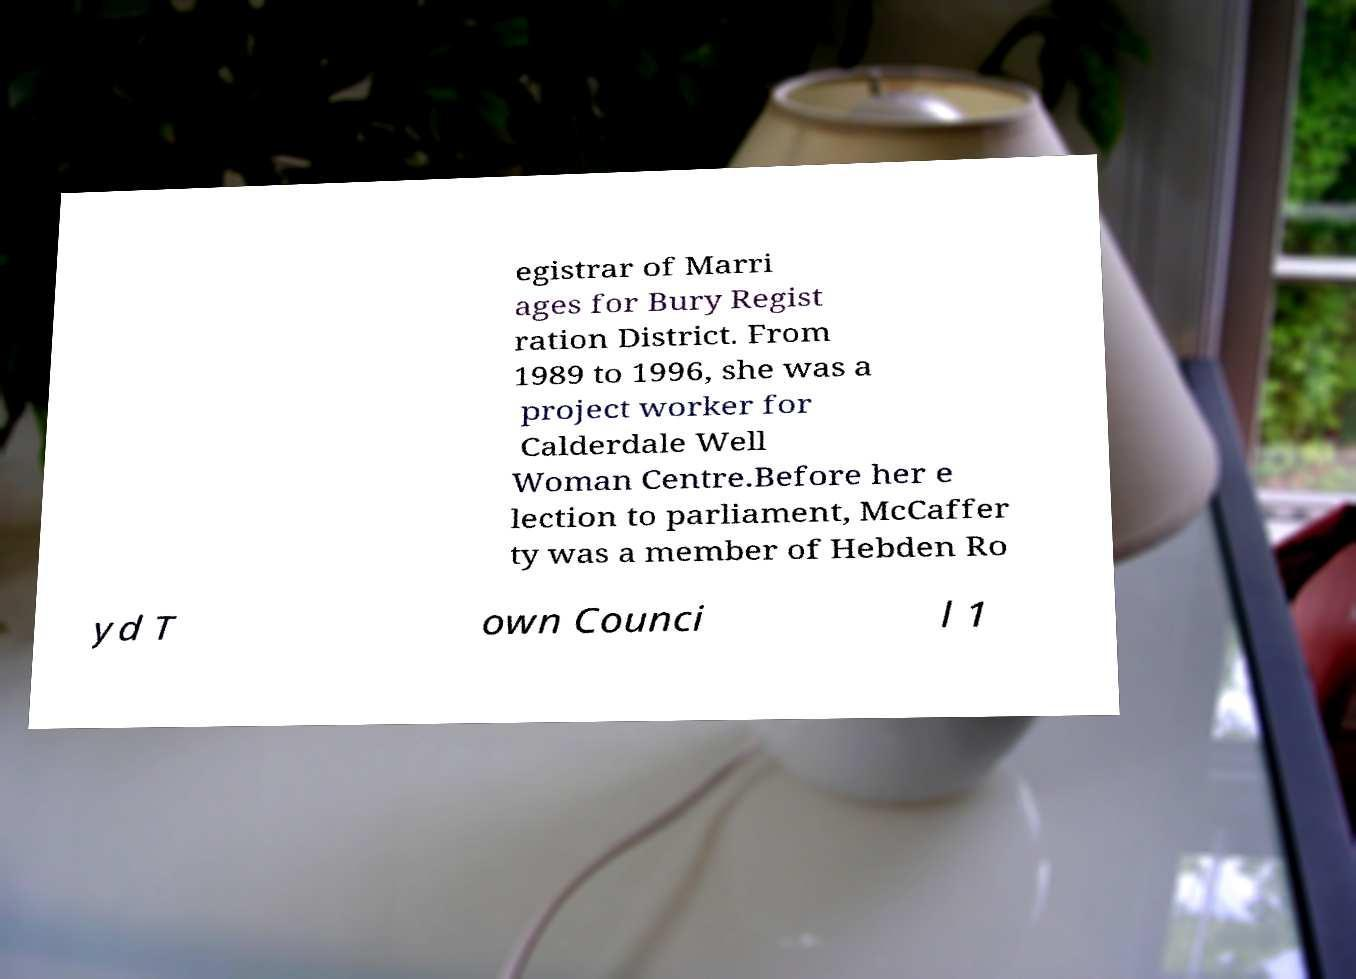Please identify and transcribe the text found in this image. egistrar of Marri ages for Bury Regist ration District. From 1989 to 1996, she was a project worker for Calderdale Well Woman Centre.Before her e lection to parliament, McCaffer ty was a member of Hebden Ro yd T own Counci l 1 